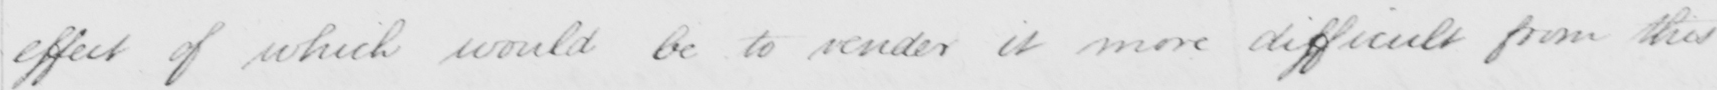Can you tell me what this handwritten text says? the effect of which would be to render it more difficult from this 